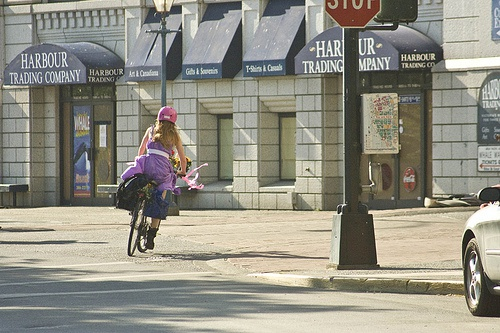Describe the objects in this image and their specific colors. I can see car in gray, black, ivory, and beige tones, people in gray, purple, violet, and brown tones, stop sign in gray, maroon, darkgray, and brown tones, bicycle in gray, black, darkgreen, and beige tones, and traffic light in gray, black, and darkgreen tones in this image. 